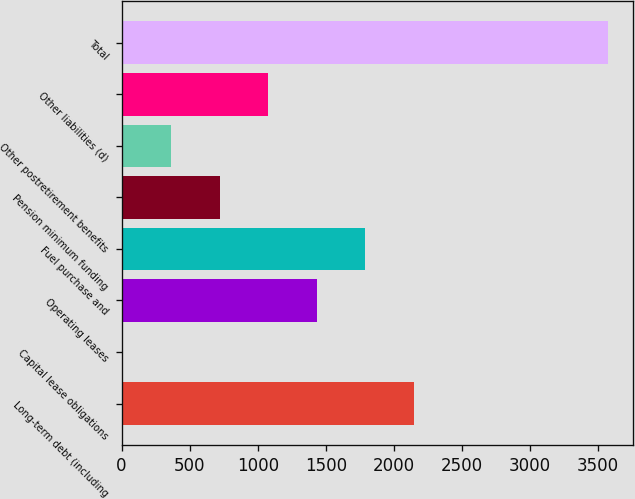<chart> <loc_0><loc_0><loc_500><loc_500><bar_chart><fcel>Long-term debt (including<fcel>Capital lease obligations<fcel>Operating leases<fcel>Fuel purchase and<fcel>Pension minimum funding<fcel>Other postretirement benefits<fcel>Other liabilities (d)<fcel>Total<nl><fcel>2147.4<fcel>6<fcel>1433.6<fcel>1790.5<fcel>719.8<fcel>362.9<fcel>1076.7<fcel>3575<nl></chart> 